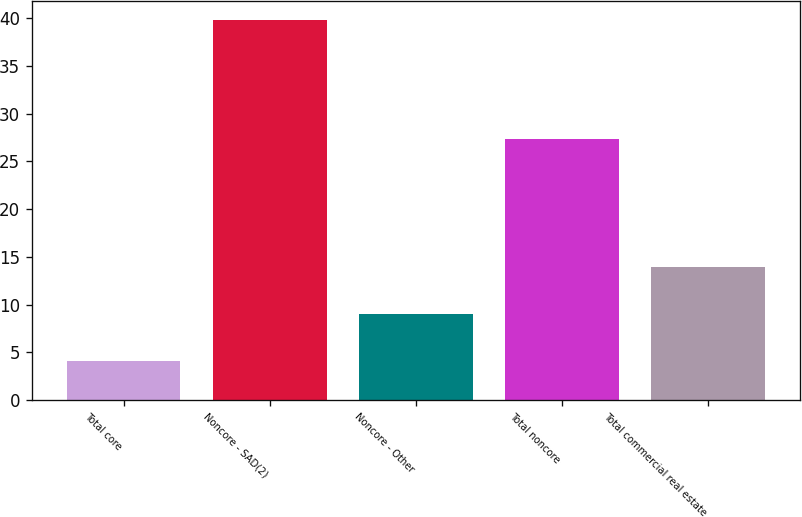<chart> <loc_0><loc_0><loc_500><loc_500><bar_chart><fcel>Total core<fcel>Noncore - SAD(2)<fcel>Noncore - Other<fcel>Total noncore<fcel>Total commercial real estate<nl><fcel>4.08<fcel>39.8<fcel>9.06<fcel>27.33<fcel>13.96<nl></chart> 